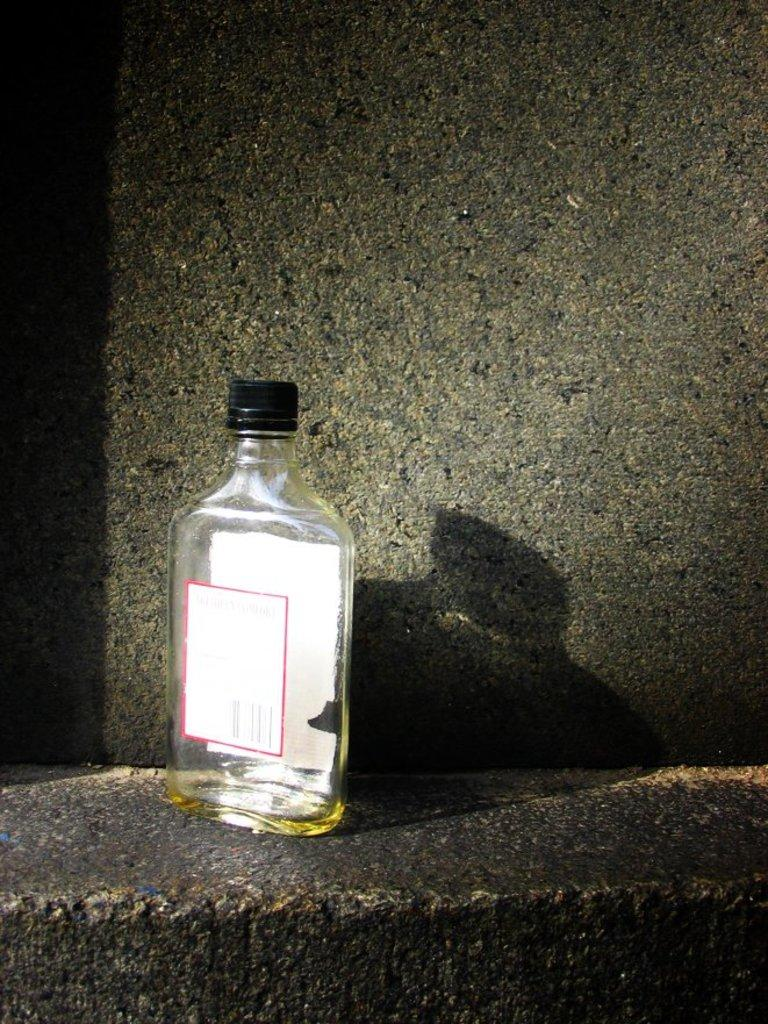What object is visible in the image that appears to be empty? There is an empty glass bottle in the image. Where is the bottle located? The bottle is on a wall. Can you describe any additional visual effects in the image? There is a reflection of the bottle and the wall in the image. What type of popcorn is being served in the vase in the image? There is no popcorn or vase present in the image; it only features an empty glass bottle on a wall. 